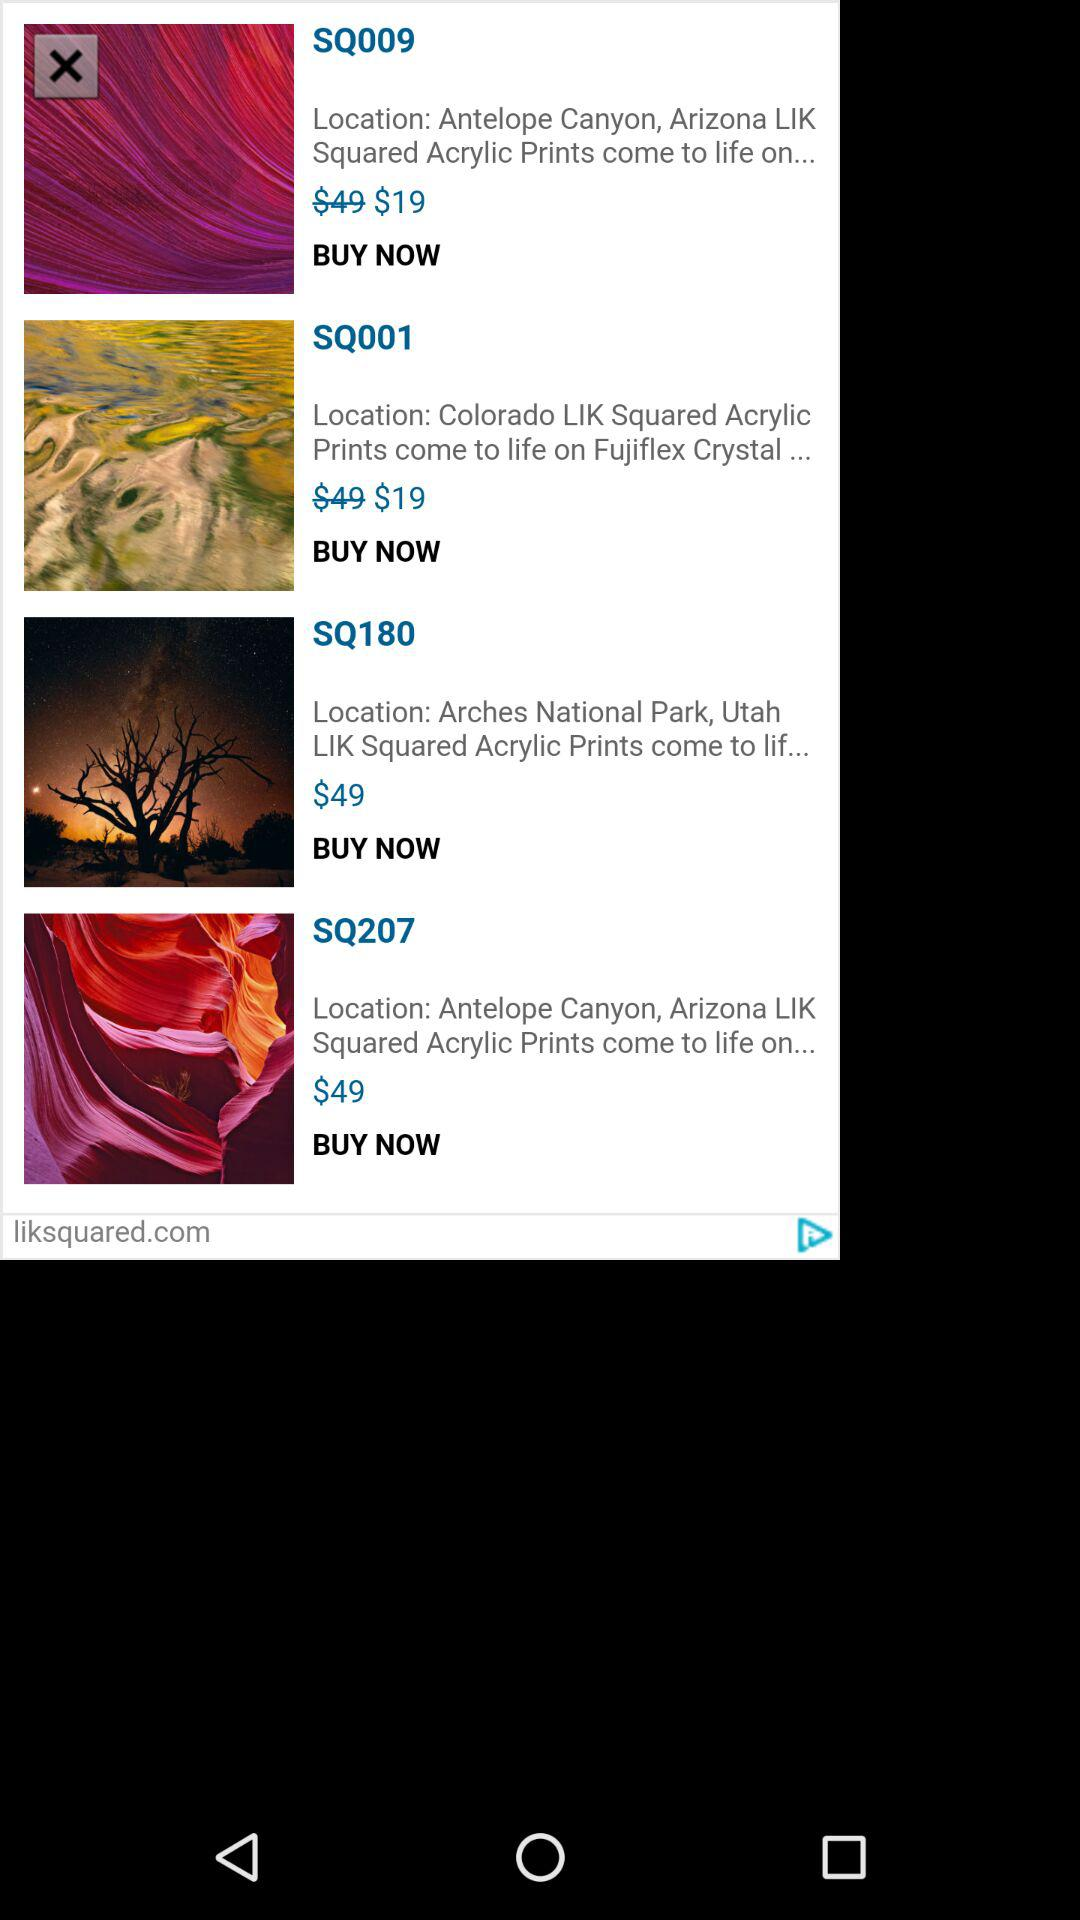What is the price of "SQ009"? The price of "SQ009" is $19. 